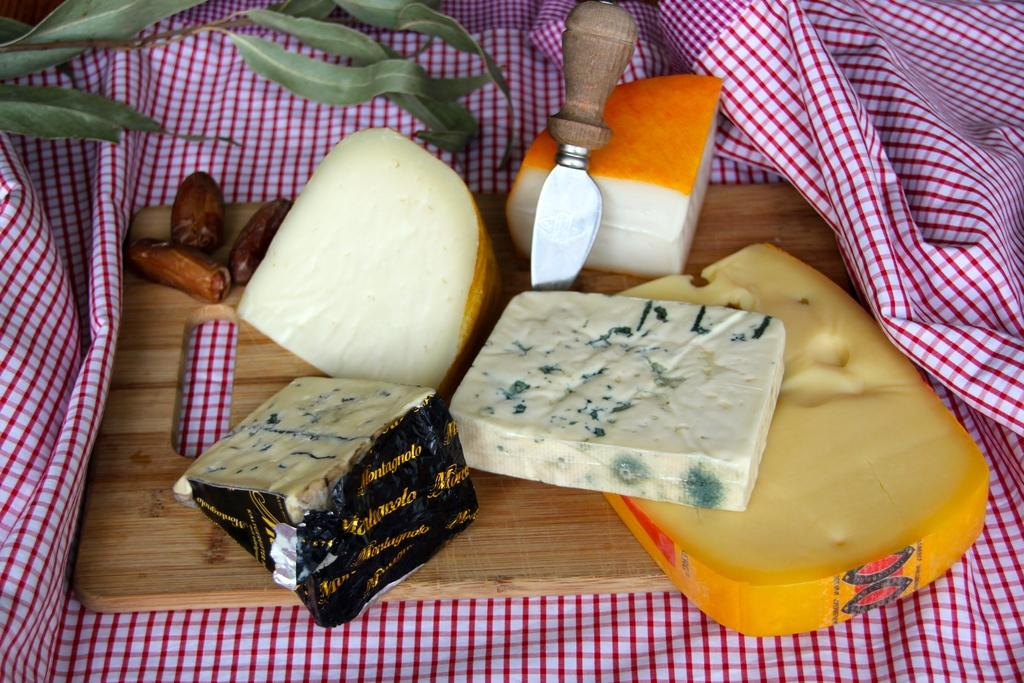What is the main object on which other items are placed in the image? There is a cutting board in the image. What is the cutting board placed on? The cutting board is on a cloth. What tool is visible in the image? There is a knife in the image. What is being prepared on the cutting board? There are food items on the cutting board. What can be seen in the background of the image? There are leaves in the background of the image. How does the pollution affect the body in the image? There is no mention of pollution or a body in the image; it features a cutting board, a cloth, a knife, food items, and leaves in the background. 